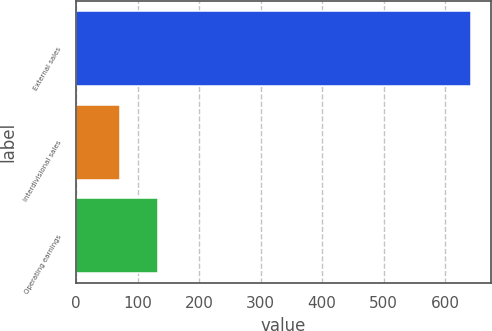Convert chart to OTSL. <chart><loc_0><loc_0><loc_500><loc_500><bar_chart><fcel>External sales<fcel>Interdivisional sales<fcel>Operating earnings<nl><fcel>642<fcel>72<fcel>133<nl></chart> 